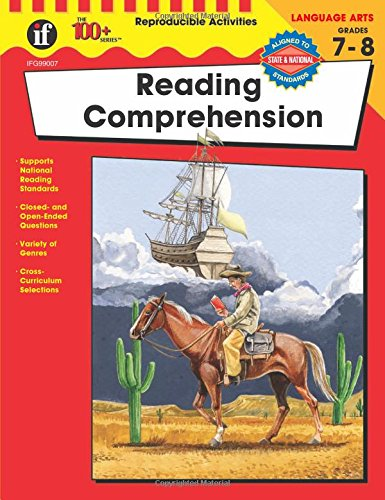What is the title of this book? The title of the book is 'Reading Comprehension, Grades 7 - 8 (The 100+ Series(TM)),' which is designed to help middle school students improve their reading skills. 